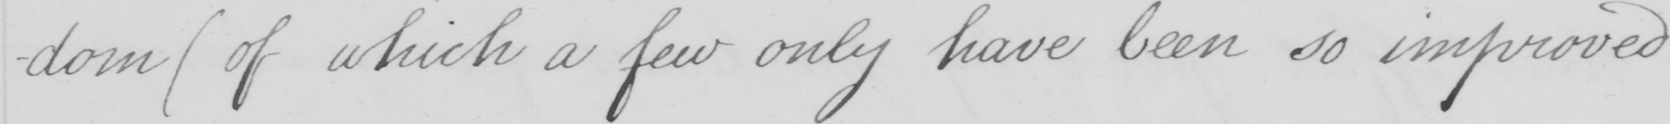What text is written in this handwritten line? -dom  ( of which a few only have been so improved 